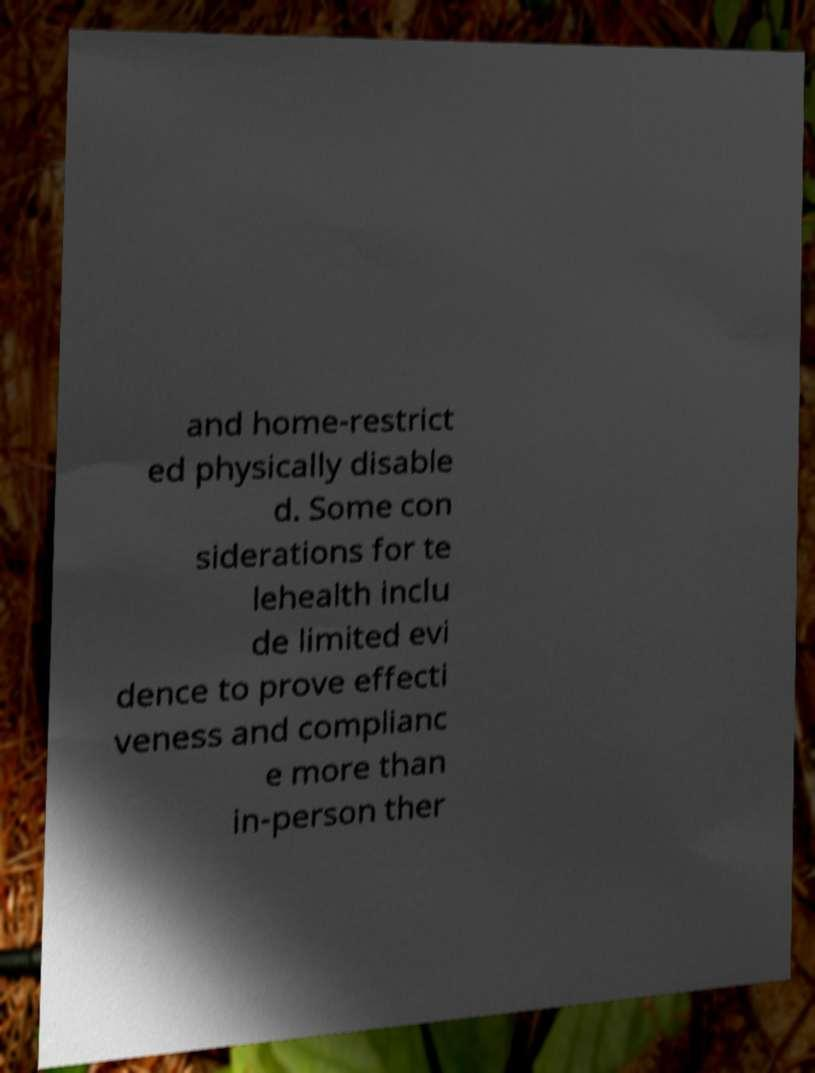For documentation purposes, I need the text within this image transcribed. Could you provide that? and home-restrict ed physically disable d. Some con siderations for te lehealth inclu de limited evi dence to prove effecti veness and complianc e more than in-person ther 